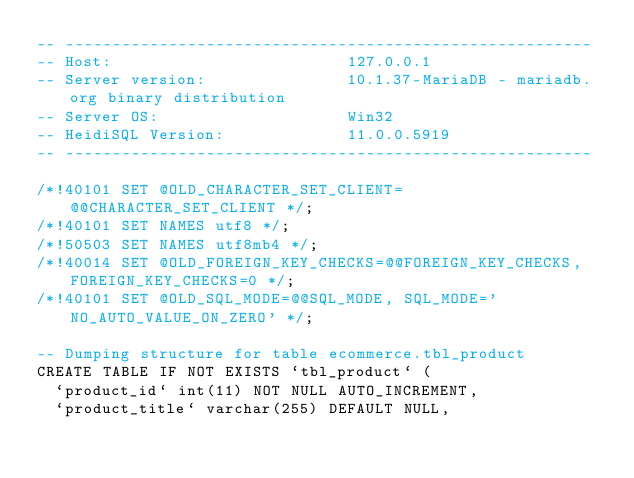Convert code to text. <code><loc_0><loc_0><loc_500><loc_500><_SQL_>-- --------------------------------------------------------
-- Host:                         127.0.0.1
-- Server version:               10.1.37-MariaDB - mariadb.org binary distribution
-- Server OS:                    Win32
-- HeidiSQL Version:             11.0.0.5919
-- --------------------------------------------------------

/*!40101 SET @OLD_CHARACTER_SET_CLIENT=@@CHARACTER_SET_CLIENT */;
/*!40101 SET NAMES utf8 */;
/*!50503 SET NAMES utf8mb4 */;
/*!40014 SET @OLD_FOREIGN_KEY_CHECKS=@@FOREIGN_KEY_CHECKS, FOREIGN_KEY_CHECKS=0 */;
/*!40101 SET @OLD_SQL_MODE=@@SQL_MODE, SQL_MODE='NO_AUTO_VALUE_ON_ZERO' */;

-- Dumping structure for table ecommerce.tbl_product
CREATE TABLE IF NOT EXISTS `tbl_product` (
  `product_id` int(11) NOT NULL AUTO_INCREMENT,
  `product_title` varchar(255) DEFAULT NULL,</code> 